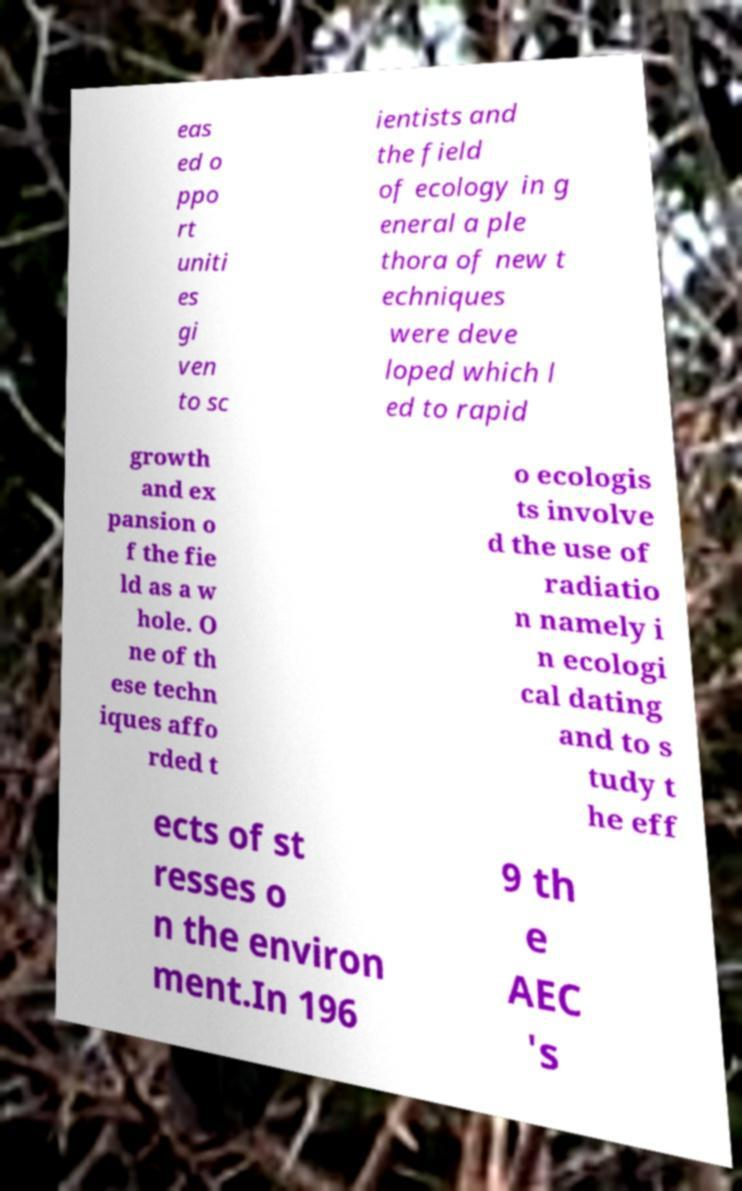I need the written content from this picture converted into text. Can you do that? eas ed o ppo rt uniti es gi ven to sc ientists and the field of ecology in g eneral a ple thora of new t echniques were deve loped which l ed to rapid growth and ex pansion o f the fie ld as a w hole. O ne of th ese techn iques affo rded t o ecologis ts involve d the use of radiatio n namely i n ecologi cal dating and to s tudy t he eff ects of st resses o n the environ ment.In 196 9 th e AEC 's 